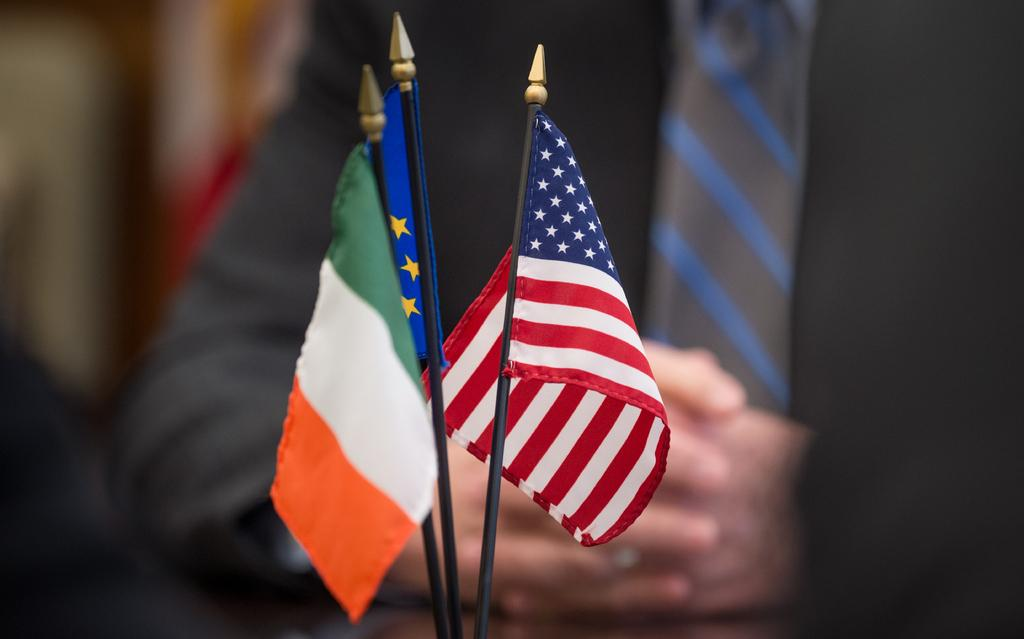What is located in the foreground of the image? There are flags in the foreground of the image. Can you describe the person in the background of the image? There is a person wearing a coat and tie in the background of the image. How many pickles are on the wall in the image? There are no pickles present in the image, and there is no mention of a wall. What type of sticks are being used by the person in the image? There is no indication of any sticks being used by the person in the image. 